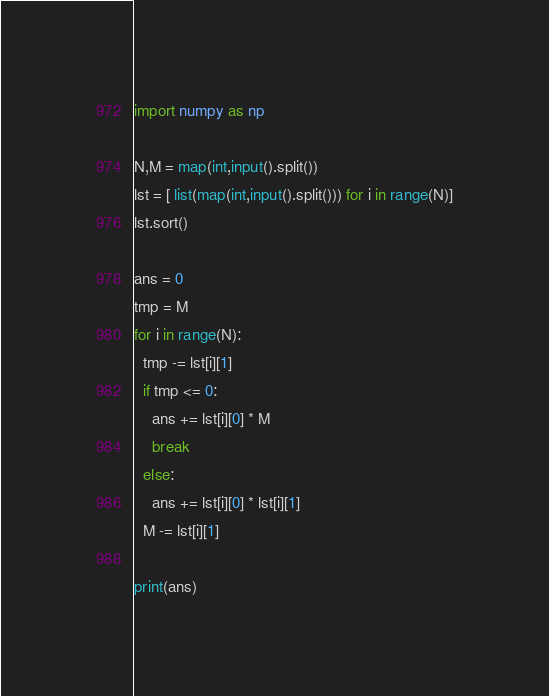Convert code to text. <code><loc_0><loc_0><loc_500><loc_500><_Python_>import numpy as np

N,M = map(int,input().split())
lst = [ list(map(int,input().split())) for i in range(N)]
lst.sort()

ans = 0
tmp = M
for i in range(N):
  tmp -= lst[i][1]
  if tmp <= 0:
    ans += lst[i][0] * M
    break
  else:
    ans += lst[i][0] * lst[i][1]
  M -= lst[i][1]

print(ans)</code> 